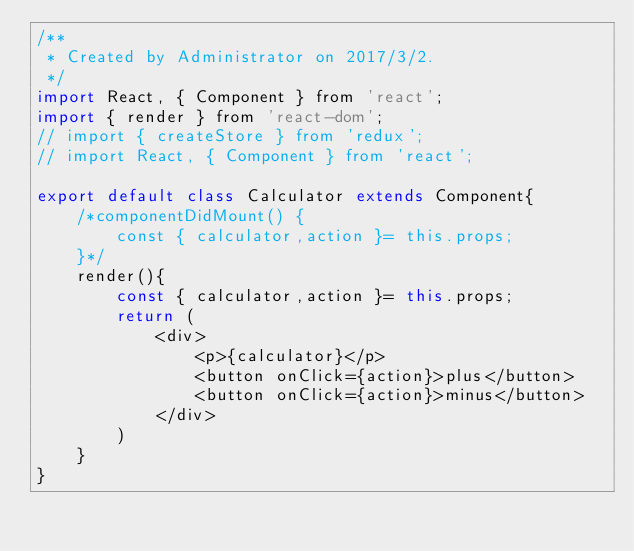Convert code to text. <code><loc_0><loc_0><loc_500><loc_500><_JavaScript_>/**
 * Created by Administrator on 2017/3/2.
 */
import React, { Component } from 'react';
import { render } from 'react-dom';
// import { createStore } from 'redux';
// import React, { Component } from 'react';

export default class Calculator extends Component{
    /*componentDidMount() {
        const { calculator,action }= this.props;
    }*/
    render(){
        const { calculator,action }= this.props;
        return (
            <div>
                <p>{calculator}</p>
                <button onClick={action}>plus</button>
                <button onClick={action}>minus</button>
            </div>
        )
    }
}


</code> 